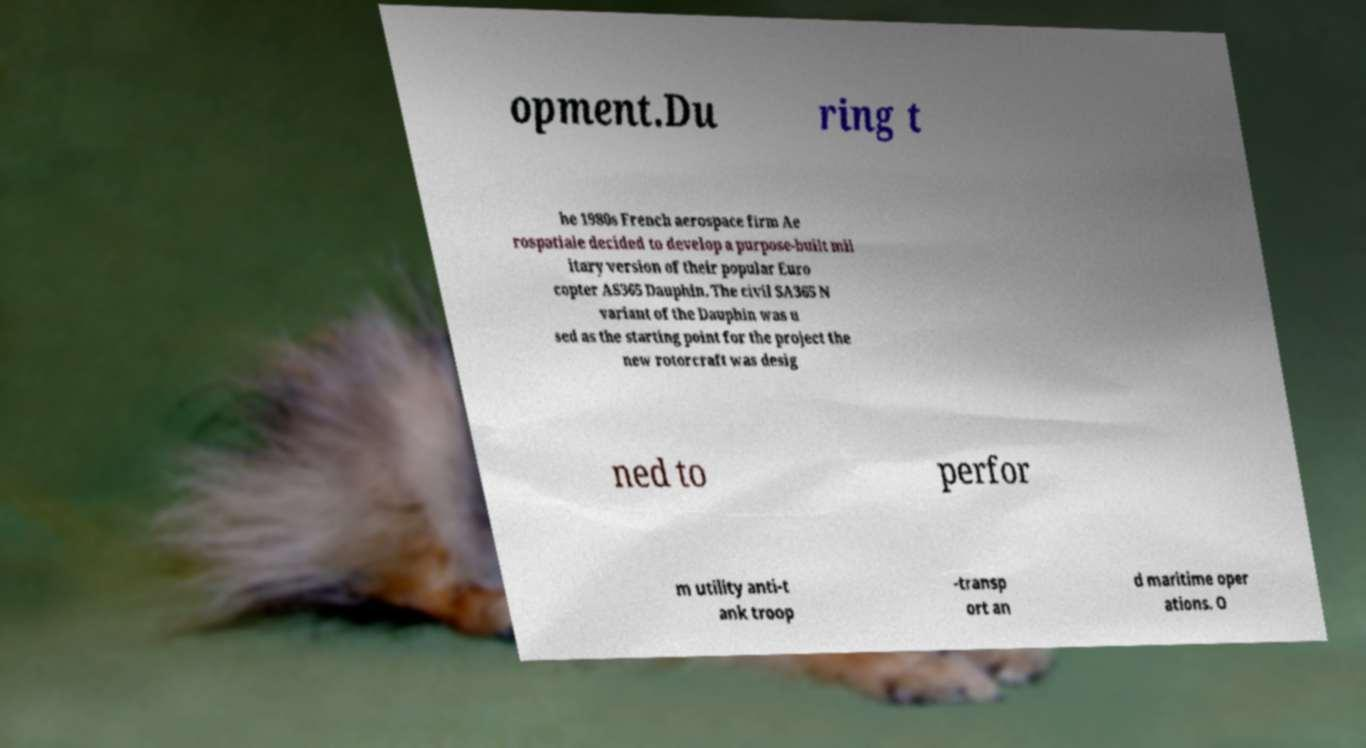There's text embedded in this image that I need extracted. Can you transcribe it verbatim? opment.Du ring t he 1980s French aerospace firm Ae rospatiale decided to develop a purpose-built mil itary version of their popular Euro copter AS365 Dauphin. The civil SA365 N variant of the Dauphin was u sed as the starting point for the project the new rotorcraft was desig ned to perfor m utility anti-t ank troop -transp ort an d maritime oper ations. O 